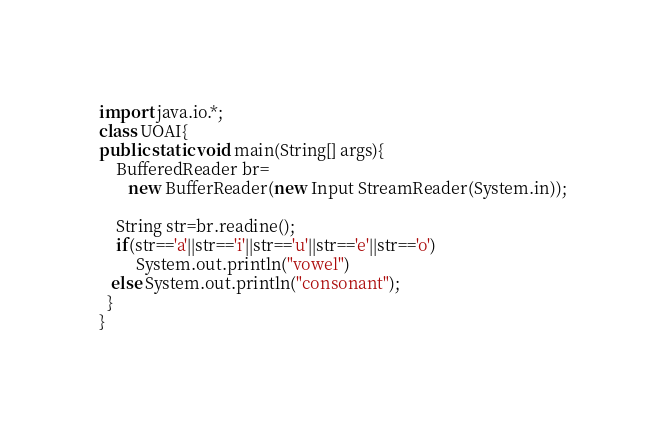Convert code to text. <code><loc_0><loc_0><loc_500><loc_500><_Java_>import java.io.*;
class UOAI{
public static void main(String[] args){
    BufferedReader br=
       new BufferReader(new Input StreamReader(System.in));
 
    String str=br.readine();
    if(str=='a'||str=='i'||str=='u'||str=='e'||str=='o')
         System.out.println("vowel")
   else System.out.println("consonant");
  }
}</code> 